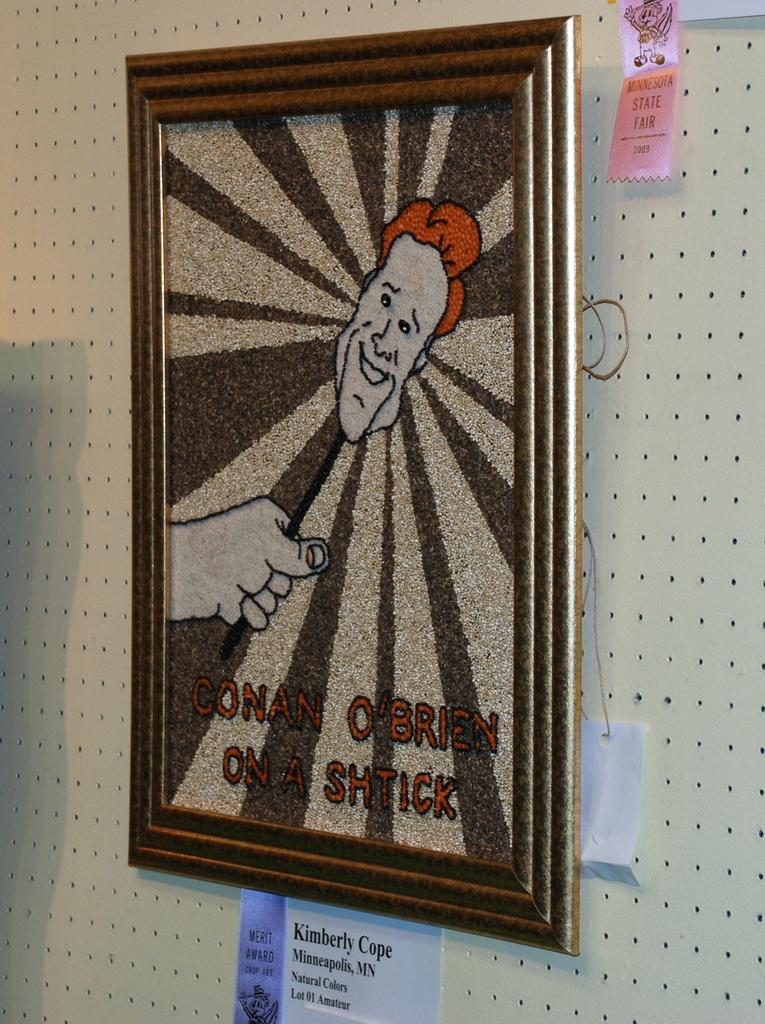Provide a one-sentence caption for the provided image. A FRAMED PICTURE OF CONAN OBRIEN ON A SHTICK. 